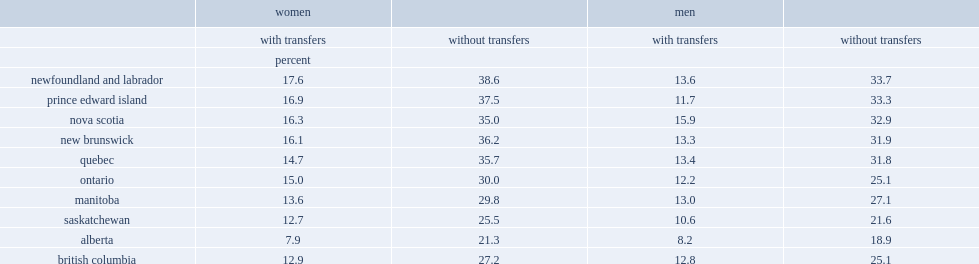In 2016, how many percentage points was the low-income rates of women and girls in newfoundland and labrador? 17.6. In 2016, how many percentage points was the low-income rates of women and girls in alberta? 7.9. How many percentage points was the low-income rates of women in ontario? 15.0. 